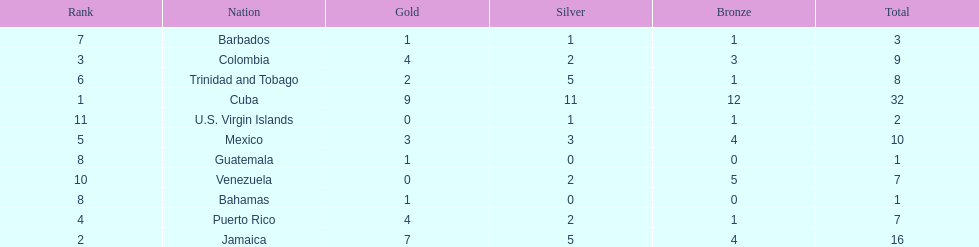Largest medal differential between countries 31. Could you parse the entire table? {'header': ['Rank', 'Nation', 'Gold', 'Silver', 'Bronze', 'Total'], 'rows': [['7', 'Barbados', '1', '1', '1', '3'], ['3', 'Colombia', '4', '2', '3', '9'], ['6', 'Trinidad and Tobago', '2', '5', '1', '8'], ['1', 'Cuba', '9', '11', '12', '32'], ['11', 'U.S. Virgin Islands', '0', '1', '1', '2'], ['5', 'Mexico', '3', '3', '4', '10'], ['8', 'Guatemala', '1', '0', '0', '1'], ['10', 'Venezuela', '0', '2', '5', '7'], ['8', 'Bahamas', '1', '0', '0', '1'], ['4', 'Puerto Rico', '4', '2', '1', '7'], ['2', 'Jamaica', '7', '5', '4', '16']]} 